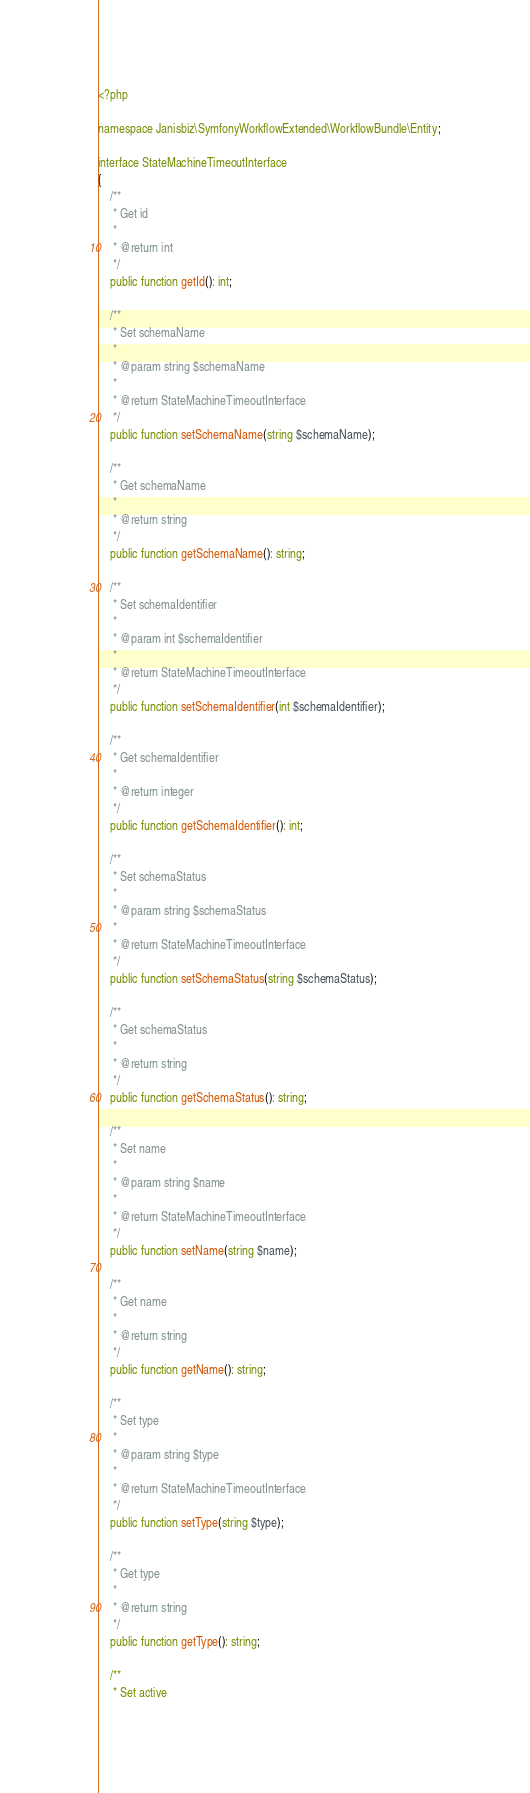Convert code to text. <code><loc_0><loc_0><loc_500><loc_500><_PHP_><?php

namespace Janisbiz\SymfonyWorkflowExtended\WorkflowBundle\Entity;

interface StateMachineTimeoutInterface
{
    /**
     * Get id
     *
     * @return int
     */
    public function getId(): int;

    /**
     * Set schemaName
     *
     * @param string $schemaName
     *
     * @return StateMachineTimeoutInterface
     */
    public function setSchemaName(string $schemaName);

    /**
     * Get schemaName
     *
     * @return string
     */
    public function getSchemaName(): string;

    /**
     * Set schemaIdentifier
     *
     * @param int $schemaIdentifier
     *
     * @return StateMachineTimeoutInterface
     */
    public function setSchemaIdentifier(int $schemaIdentifier);

    /**
     * Get schemaIdentifier
     *
     * @return integer
     */
    public function getSchemaIdentifier(): int;

    /**
     * Set schemaStatus
     *
     * @param string $schemaStatus
     *
     * @return StateMachineTimeoutInterface
     */
    public function setSchemaStatus(string $schemaStatus);

    /**
     * Get schemaStatus
     *
     * @return string
     */
    public function getSchemaStatus(): string;

    /**
     * Set name
     *
     * @param string $name
     *
     * @return StateMachineTimeoutInterface
     */
    public function setName(string $name);

    /**
     * Get name
     *
     * @return string
     */
    public function getName(): string;

    /**
     * Set type
     *
     * @param string $type
     *
     * @return StateMachineTimeoutInterface
     */
    public function setType(string $type);

    /**
     * Get type
     *
     * @return string
     */
    public function getType(): string;

    /**
     * Set active</code> 